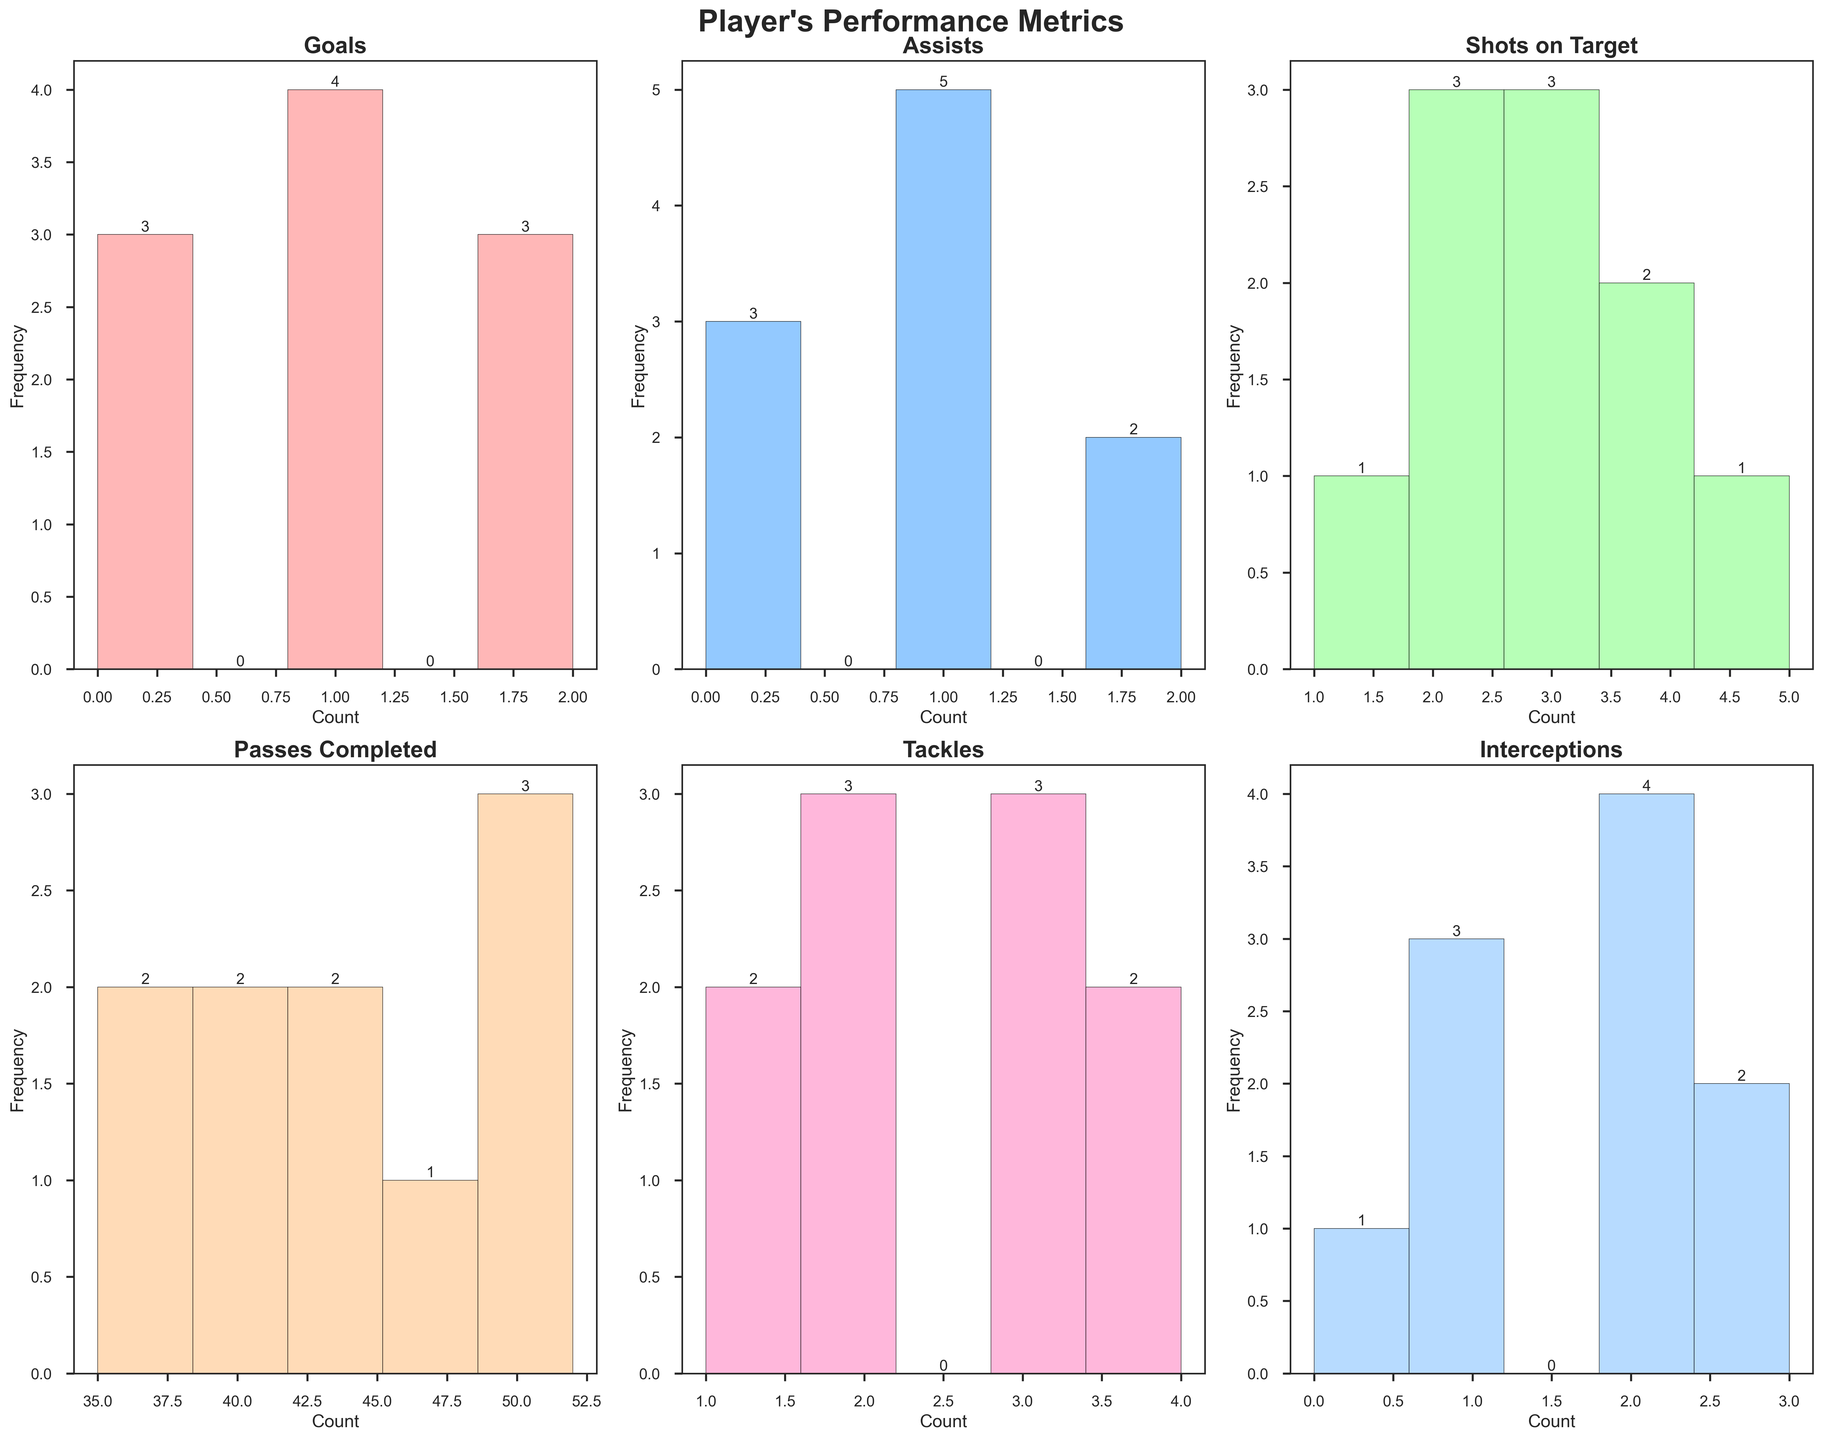what's the title of the figure? The title of the figure is usually located at the top of the plot. For this specific plot, it is explicitly set in the code with the `fig.suptitle` function. By reading this, we can see the title is "Player's Performance Metrics."
Answer: Player's Performance Metrics What is the x-axis label for the 'Goals' subplot? Each subplot has a title, x-axis label, and y-axis label. For the 'Goals' subplot, the x-axis label is set to 'Count' with the `ax.set_xlabel` function.
Answer: Count Which performance metric has the highest frequency bar? To find the highest frequency bar, look for the tallest bar across all subplots. From visual inspection, 'Passes Completed' has the tallest bar, indicating the highest frequency.
Answer: Passes Completed How many performance metrics are displayed in the figure? The figure contains one histogram for each performance metric. We can count the number of subplots, which is 6 in total.
Answer: 6 How many bins are used in each histogram? In the code, the number of bins for each histogram is set to 5 using the `bins=5` parameter in the `ax.hist` function for each subplot.
Answer: 5 What is the range of the x-axis for 'Tackles'? The range of the x-axis for 'Tackles' can be determined by looking at the width of the histogram bars. Each bar covers equal intervals, starting from the minimum to the maximum value. The x-axis range for 'Tackles' goes from 0 to 5.
Answer: 0 to 5 Which match had the highest number of 'Shots on Target'? Each histogram bar represents the frequency of a specific value. By finding the tallest bar for 'Shots on Target', we see it corresponds to 4 (frequency of 2). Match vs Liverpool and Match vs West Ham had 4 shots each.
Answer: vs Liverpool, vs West Ham What was the median number of 'Goals' scored in these 10 matches? Median is the middle value in a sorted list. We sort the number of goals: [0, 0, 0, 1, 1, 1, 1, 2, 2, 2]. The median of these values is the middle one, which is 1.
Answer: 1 Compare the frequency of 'Tackles' to 'Interceptions'. Which has a higher mode? Mode refers to the value that appears most frequently. Compare the highest bars for 'Tackles' and 'Interceptions'. Both have multiple values tied at the highest frequency of 3, making both metrics equally frequent.
Answer: Equal Which performance metric had the lowest maximum value? To determine this, we observe the histograms and find the one with the least upper bound on the x-axis. 'Interceptions' have values only up to 3, making them the lowest maximum value.
Answer: Interceptions 